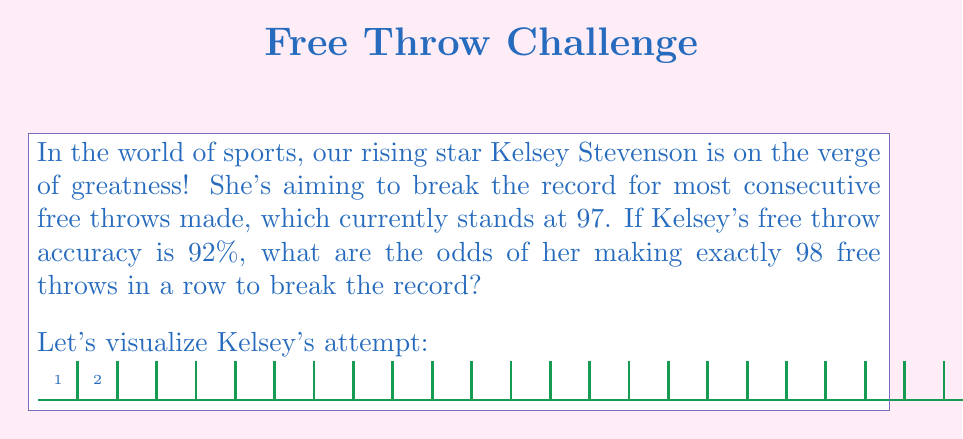Could you help me with this problem? To solve this problem, we need to use the concept of geometric probability. Here's a step-by-step explanation:

1) The probability of making a single free throw is 92% or 0.92.

2) For Kelsey to break the record with exactly 98 free throws, she needs to:
   a) Make 98 consecutive free throws (probability: $0.92^{98}$)
   b) Miss the 99th free throw (probability: $1 - 0.92 = 0.08$)

3) The probability of both these events occurring is the product of their individual probabilities:

   $$P(\text{98 consecutive makes, then a miss}) = 0.92^{98} \times 0.08$$

4) Let's calculate this step by step:
   
   $$0.92^{98} = 0.0006709883...$$
   
   $$0.0006709883... \times 0.08 = 0.00005367906...$$

5) To express this as odds, we divide the probability by (1 - probability):

   $$\text{Odds} = \frac{0.00005367906...}{1 - 0.00005367906...} = 0.00005367909...$$

6) This can be expressed as approximately 1 in 18,629.

Therefore, the odds of Kelsey Stevenson breaking the record with exactly 98 consecutive free throws are about 1 in 18,629.
Answer: $\frac{1}{18629}$ or approximately 0.0000537:1 